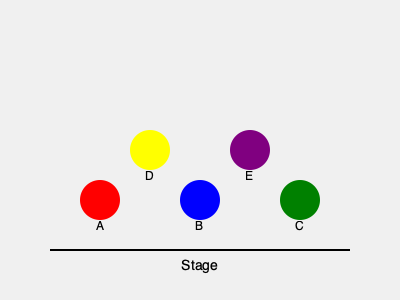In your historical musical, you need to create a visually balanced tableau for a pivotal scene. Given the stage arrangement shown, with actors A, B, and C in the front row and actors D and E in the back row, which actor should be moved to position (200, 150) to create perfect symmetry? To create perfect symmetry in this tableau, we need to consider the following steps:

1. Analyze the current arrangement:
   - Front row: A (100, 200), B (200, 200), C (300, 200)
   - Back row: D (150, 150), E (250, 150)

2. Identify the axis of symmetry:
   - The center of the stage is at x = 200

3. Evaluate the symmetry:
   - A and C are equidistant from the center (100 units)
   - D and E are equidistant from the center (50 units)
   - B is already at the center (200, 200)

4. Determine the missing position:
   - To achieve perfect symmetry, we need an actor at (200, 150)
   - This position would be directly above B and centered between D and E

5. Choose the actor to move:
   - Moving any actor from the front row (A, B, or C) would disrupt the balanced front line
   - Either D or E can be moved to (200, 150) without affecting the overall balance

6. Select the actor that requires the least movement:
   - D would move 50 units right
   - E would move 50 units left
   - Both options are equivalent in terms of distance

Therefore, either D or E can be moved to position (200, 150) to create perfect symmetry. For the sake of a definitive answer, we'll choose the actor that appears first alphabetically.
Answer: D 